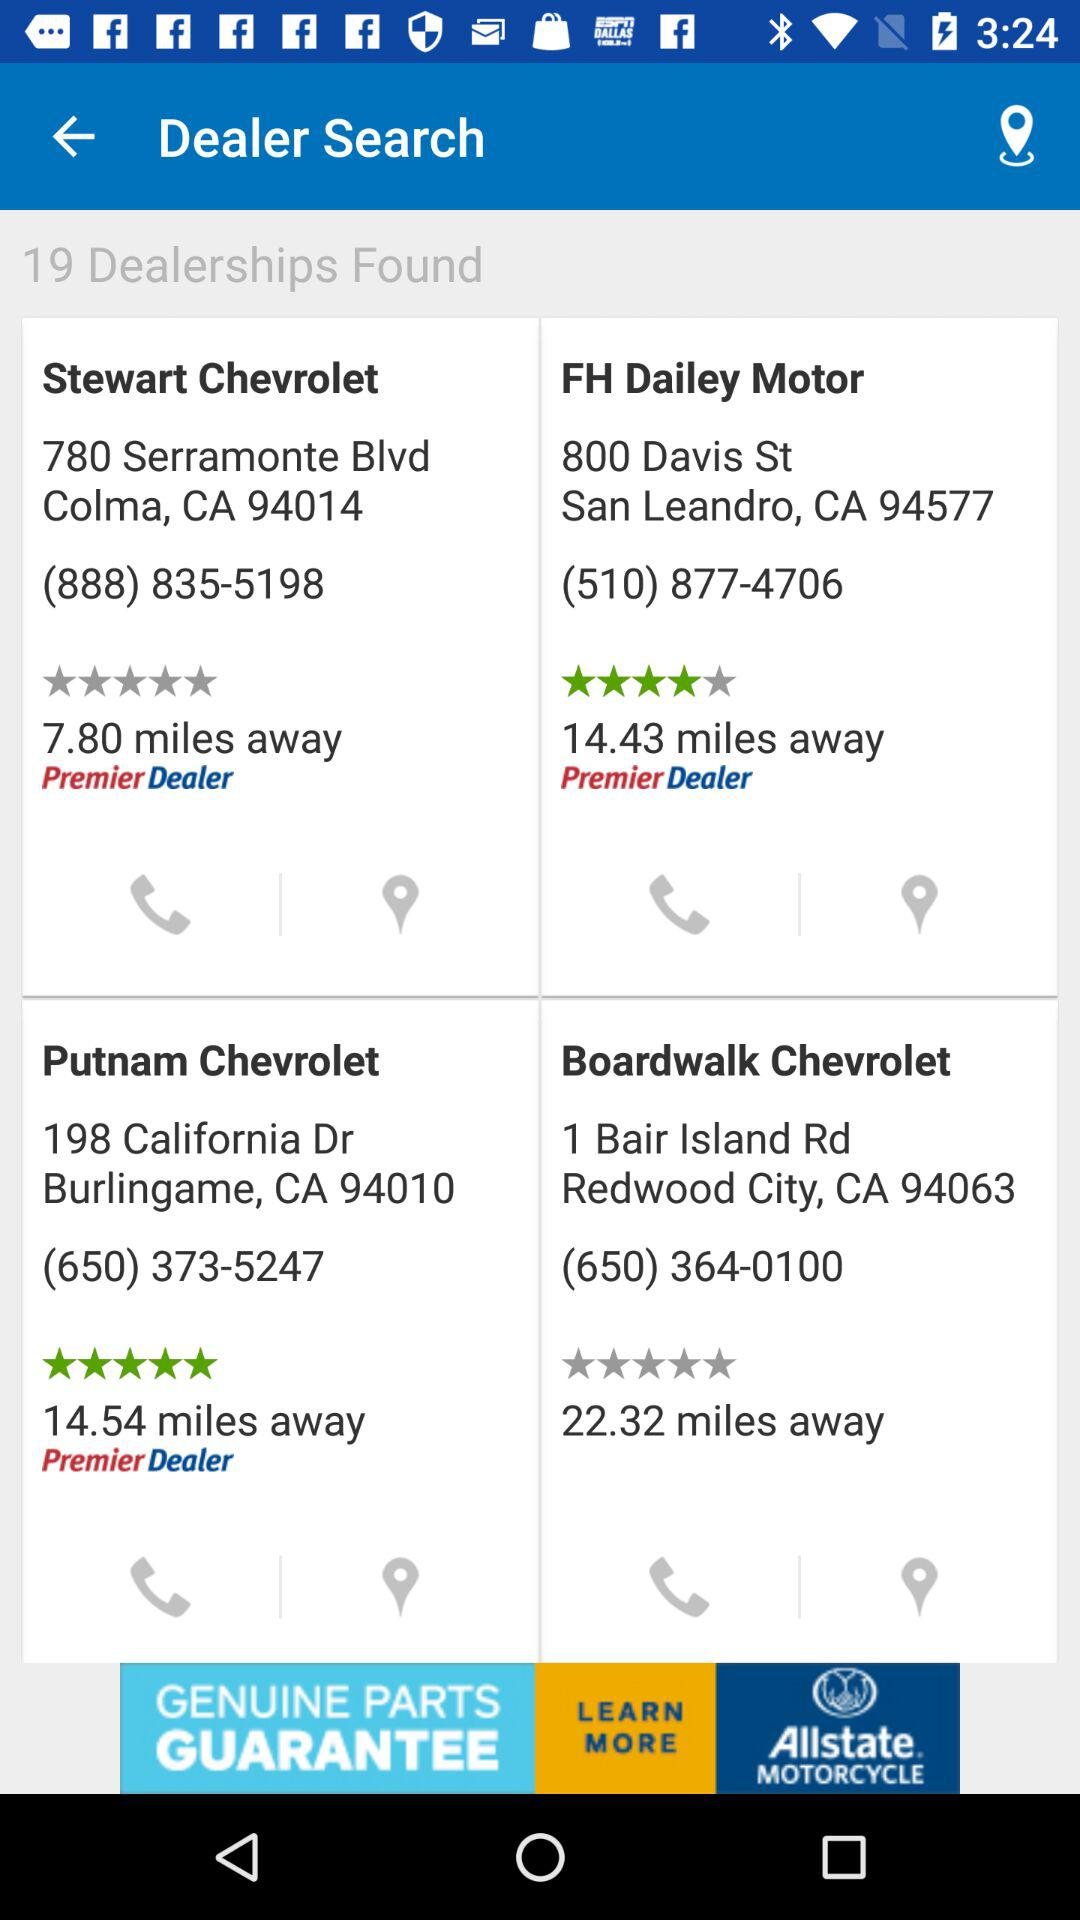What is the rating of "FH Dailey Motor"? The rating of "FH Dailey Motor" is 4 stars. 